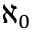<formula> <loc_0><loc_0><loc_500><loc_500>\aleph _ { 0 }</formula> 